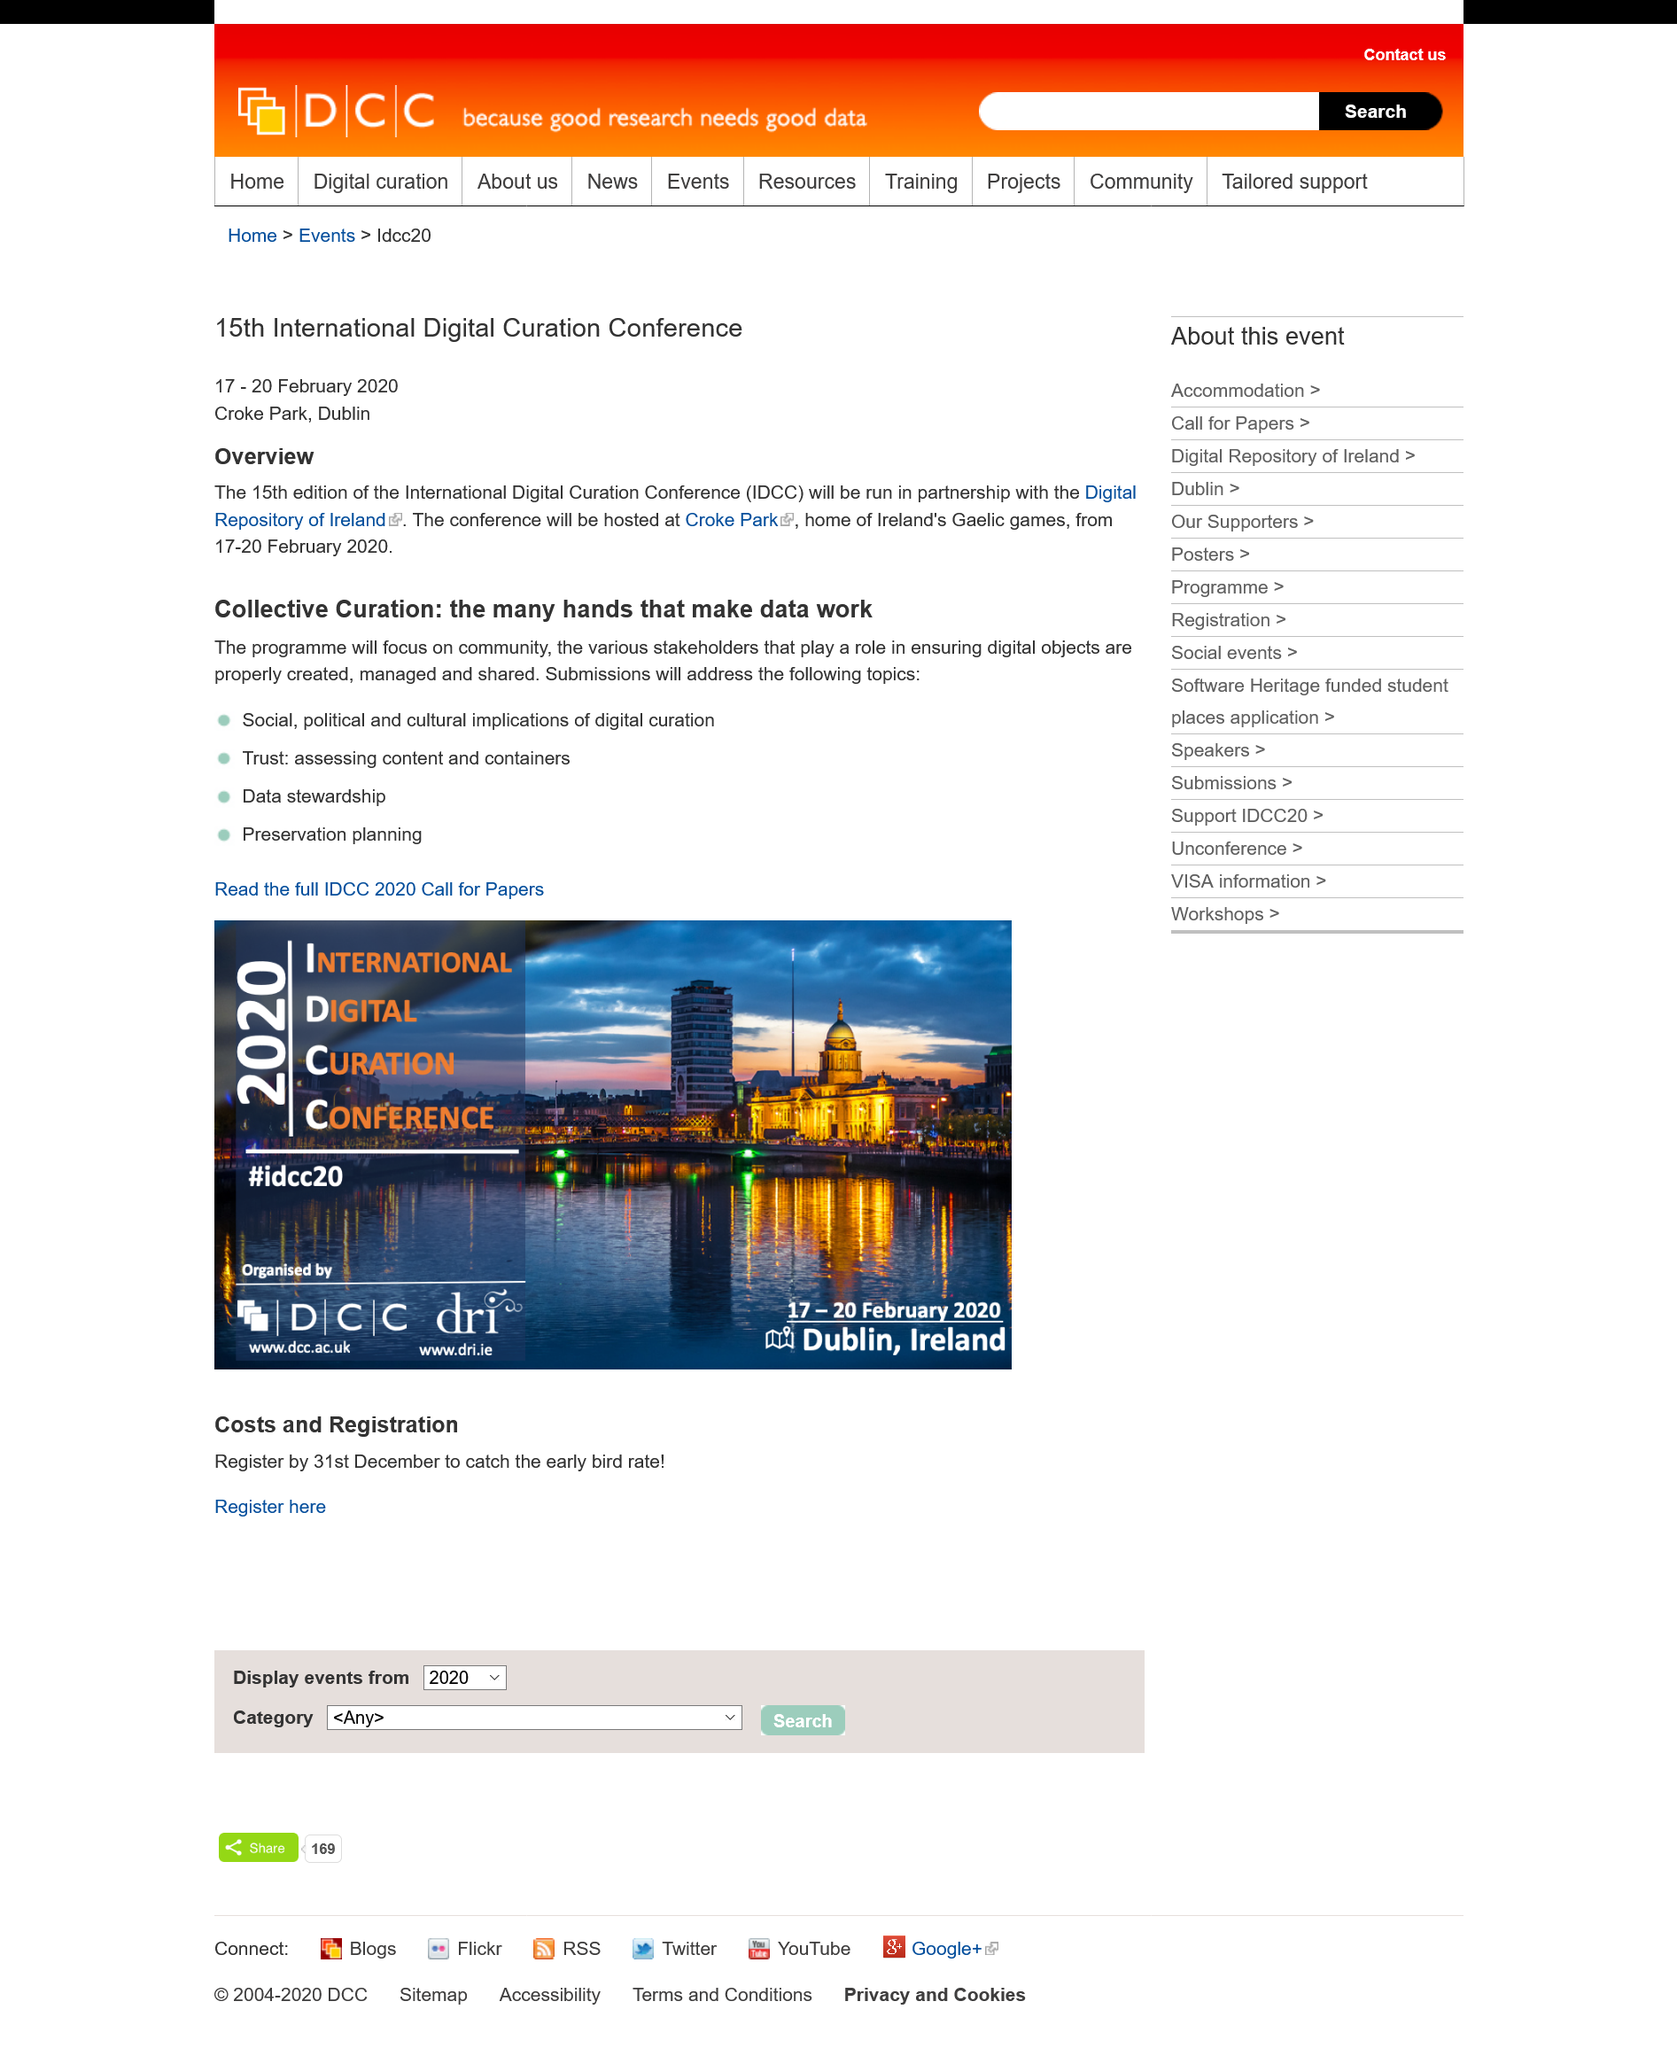Highlight a few significant elements in this photo. The 15th International Digital Curation Conference took place from 17-20 February 2020. The acronym IDCC stands for the International Digital Curation Conference. Croke Park is the home of Ireland's Gaelic games. 